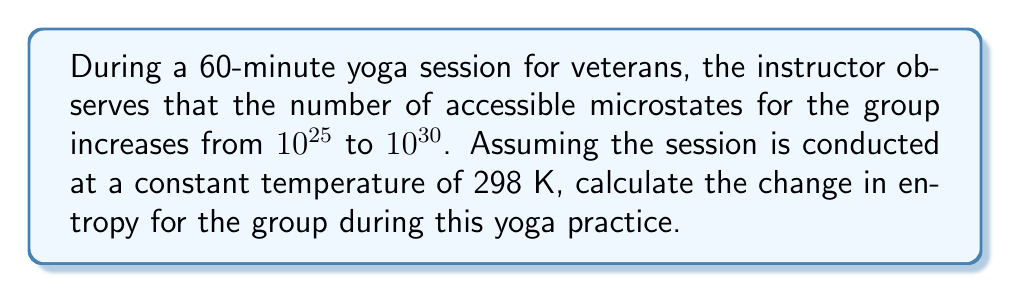Teach me how to tackle this problem. To solve this problem, we'll use the Boltzmann entropy formula and the given information. Let's proceed step-by-step:

1) The Boltzmann entropy formula is:

   $$S = k_B \ln \Omega$$

   Where:
   $S$ is entropy
   $k_B$ is the Boltzmann constant ($1.380649 \times 10^{-23}$ J/K)
   $\Omega$ is the number of microstates

2) We need to calculate the change in entropy ($\Delta S$), which is the difference between the final and initial entropies:

   $$\Delta S = S_f - S_i = k_B \ln \Omega_f - k_B \ln \Omega_i$$

3) Substituting the given values:
   $\Omega_i = 10^{25}$ (initial microstates)
   $\Omega_f = 10^{30}$ (final microstates)

4) We can simplify the equation:

   $$\Delta S = k_B (\ln \Omega_f - \ln \Omega_i) = k_B \ln (\frac{\Omega_f}{\Omega_i})$$

5) Substituting the values:

   $$\Delta S = (1.380649 \times 10^{-23} \text{ J/K}) \ln (\frac{10^{30}}{10^{25}})$$

6) Simplify:

   $$\Delta S = (1.380649 \times 10^{-23} \text{ J/K}) \ln (10^5)$$

7) Calculate:

   $$\Delta S = (1.380649 \times 10^{-23} \text{ J/K}) (5 \ln 10) \approx 1.59 \times 10^{-22} \text{ J/K}$$

8) To convert to J/K per person, assuming a typical class size of 20 veterans:

   $$\Delta S_{per person} = \frac{1.59 \times 10^{-22} \text{ J/K}}{20} \approx 7.95 \times 10^{-24} \text{ J/K}$$
Answer: $7.95 \times 10^{-24}$ J/K per person 